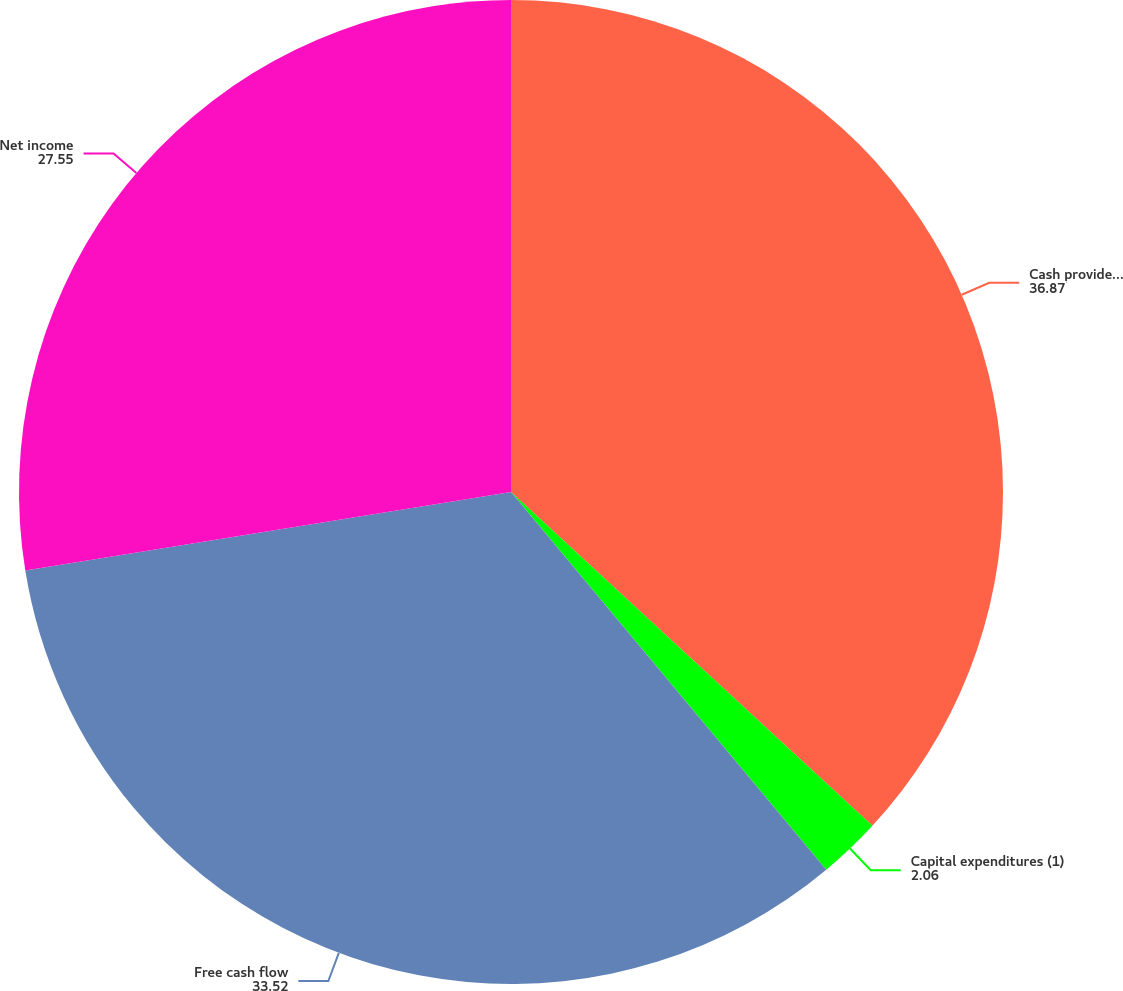Convert chart to OTSL. <chart><loc_0><loc_0><loc_500><loc_500><pie_chart><fcel>Cash provided by operating<fcel>Capital expenditures (1)<fcel>Free cash flow<fcel>Net income<nl><fcel>36.87%<fcel>2.06%<fcel>33.52%<fcel>27.55%<nl></chart> 